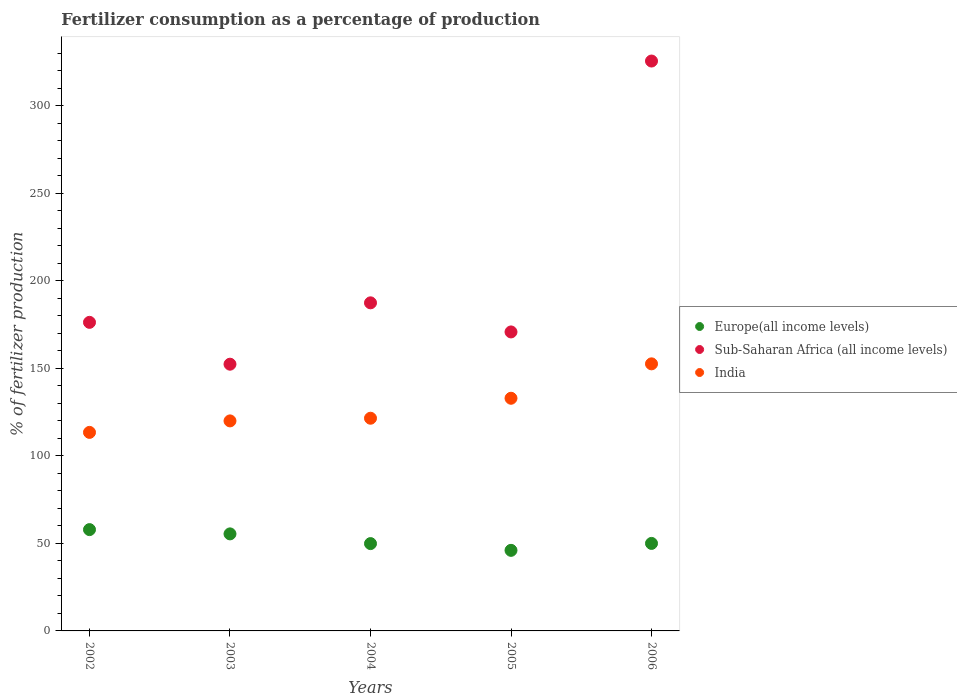Is the number of dotlines equal to the number of legend labels?
Provide a short and direct response. Yes. What is the percentage of fertilizers consumed in Sub-Saharan Africa (all income levels) in 2003?
Make the answer very short. 152.35. Across all years, what is the maximum percentage of fertilizers consumed in Sub-Saharan Africa (all income levels)?
Offer a terse response. 325.51. Across all years, what is the minimum percentage of fertilizers consumed in India?
Provide a short and direct response. 113.4. In which year was the percentage of fertilizers consumed in Europe(all income levels) maximum?
Your response must be concise. 2002. What is the total percentage of fertilizers consumed in India in the graph?
Give a very brief answer. 640.3. What is the difference between the percentage of fertilizers consumed in Europe(all income levels) in 2004 and that in 2005?
Your answer should be very brief. 3.86. What is the difference between the percentage of fertilizers consumed in India in 2002 and the percentage of fertilizers consumed in Sub-Saharan Africa (all income levels) in 2005?
Your answer should be very brief. -57.38. What is the average percentage of fertilizers consumed in Sub-Saharan Africa (all income levels) per year?
Keep it short and to the point. 202.46. In the year 2006, what is the difference between the percentage of fertilizers consumed in Europe(all income levels) and percentage of fertilizers consumed in India?
Give a very brief answer. -102.57. In how many years, is the percentage of fertilizers consumed in Europe(all income levels) greater than 210 %?
Offer a terse response. 0. What is the ratio of the percentage of fertilizers consumed in Sub-Saharan Africa (all income levels) in 2002 to that in 2006?
Offer a terse response. 0.54. Is the difference between the percentage of fertilizers consumed in Europe(all income levels) in 2005 and 2006 greater than the difference between the percentage of fertilizers consumed in India in 2005 and 2006?
Your response must be concise. Yes. What is the difference between the highest and the second highest percentage of fertilizers consumed in India?
Give a very brief answer. 19.66. What is the difference between the highest and the lowest percentage of fertilizers consumed in Europe(all income levels)?
Your answer should be compact. 11.84. Is the sum of the percentage of fertilizers consumed in India in 2002 and 2004 greater than the maximum percentage of fertilizers consumed in Europe(all income levels) across all years?
Provide a short and direct response. Yes. Does the percentage of fertilizers consumed in India monotonically increase over the years?
Your answer should be compact. Yes. Is the percentage of fertilizers consumed in India strictly greater than the percentage of fertilizers consumed in Europe(all income levels) over the years?
Make the answer very short. Yes. How many dotlines are there?
Your response must be concise. 3. Are the values on the major ticks of Y-axis written in scientific E-notation?
Your answer should be compact. No. Does the graph contain any zero values?
Your answer should be compact. No. What is the title of the graph?
Provide a short and direct response. Fertilizer consumption as a percentage of production. Does "Hong Kong" appear as one of the legend labels in the graph?
Ensure brevity in your answer.  No. What is the label or title of the Y-axis?
Ensure brevity in your answer.  % of fertilizer production. What is the % of fertilizer production of Europe(all income levels) in 2002?
Give a very brief answer. 57.87. What is the % of fertilizer production in Sub-Saharan Africa (all income levels) in 2002?
Keep it short and to the point. 176.25. What is the % of fertilizer production in India in 2002?
Your answer should be compact. 113.4. What is the % of fertilizer production in Europe(all income levels) in 2003?
Offer a very short reply. 55.43. What is the % of fertilizer production of Sub-Saharan Africa (all income levels) in 2003?
Offer a very short reply. 152.35. What is the % of fertilizer production in India in 2003?
Give a very brief answer. 119.96. What is the % of fertilizer production in Europe(all income levels) in 2004?
Ensure brevity in your answer.  49.88. What is the % of fertilizer production of Sub-Saharan Africa (all income levels) in 2004?
Provide a succinct answer. 187.4. What is the % of fertilizer production of India in 2004?
Keep it short and to the point. 121.49. What is the % of fertilizer production in Europe(all income levels) in 2005?
Your response must be concise. 46.02. What is the % of fertilizer production in Sub-Saharan Africa (all income levels) in 2005?
Give a very brief answer. 170.78. What is the % of fertilizer production of India in 2005?
Offer a terse response. 132.9. What is the % of fertilizer production in Europe(all income levels) in 2006?
Ensure brevity in your answer.  49.98. What is the % of fertilizer production of Sub-Saharan Africa (all income levels) in 2006?
Provide a short and direct response. 325.51. What is the % of fertilizer production of India in 2006?
Offer a terse response. 152.55. Across all years, what is the maximum % of fertilizer production of Europe(all income levels)?
Keep it short and to the point. 57.87. Across all years, what is the maximum % of fertilizer production of Sub-Saharan Africa (all income levels)?
Provide a short and direct response. 325.51. Across all years, what is the maximum % of fertilizer production of India?
Your response must be concise. 152.55. Across all years, what is the minimum % of fertilizer production of Europe(all income levels)?
Provide a succinct answer. 46.02. Across all years, what is the minimum % of fertilizer production in Sub-Saharan Africa (all income levels)?
Make the answer very short. 152.35. Across all years, what is the minimum % of fertilizer production in India?
Your response must be concise. 113.4. What is the total % of fertilizer production in Europe(all income levels) in the graph?
Your answer should be very brief. 259.18. What is the total % of fertilizer production of Sub-Saharan Africa (all income levels) in the graph?
Provide a short and direct response. 1012.29. What is the total % of fertilizer production in India in the graph?
Your response must be concise. 640.3. What is the difference between the % of fertilizer production of Europe(all income levels) in 2002 and that in 2003?
Provide a short and direct response. 2.44. What is the difference between the % of fertilizer production in Sub-Saharan Africa (all income levels) in 2002 and that in 2003?
Your answer should be compact. 23.9. What is the difference between the % of fertilizer production of India in 2002 and that in 2003?
Your response must be concise. -6.56. What is the difference between the % of fertilizer production of Europe(all income levels) in 2002 and that in 2004?
Your answer should be compact. 7.99. What is the difference between the % of fertilizer production in Sub-Saharan Africa (all income levels) in 2002 and that in 2004?
Your answer should be compact. -11.14. What is the difference between the % of fertilizer production of India in 2002 and that in 2004?
Offer a very short reply. -8.09. What is the difference between the % of fertilizer production in Europe(all income levels) in 2002 and that in 2005?
Provide a succinct answer. 11.84. What is the difference between the % of fertilizer production in Sub-Saharan Africa (all income levels) in 2002 and that in 2005?
Your answer should be compact. 5.48. What is the difference between the % of fertilizer production in India in 2002 and that in 2005?
Give a very brief answer. -19.49. What is the difference between the % of fertilizer production of Europe(all income levels) in 2002 and that in 2006?
Offer a terse response. 7.88. What is the difference between the % of fertilizer production of Sub-Saharan Africa (all income levels) in 2002 and that in 2006?
Your answer should be very brief. -149.25. What is the difference between the % of fertilizer production of India in 2002 and that in 2006?
Give a very brief answer. -39.15. What is the difference between the % of fertilizer production of Europe(all income levels) in 2003 and that in 2004?
Offer a terse response. 5.55. What is the difference between the % of fertilizer production in Sub-Saharan Africa (all income levels) in 2003 and that in 2004?
Give a very brief answer. -35.04. What is the difference between the % of fertilizer production in India in 2003 and that in 2004?
Your answer should be compact. -1.53. What is the difference between the % of fertilizer production in Europe(all income levels) in 2003 and that in 2005?
Provide a short and direct response. 9.4. What is the difference between the % of fertilizer production in Sub-Saharan Africa (all income levels) in 2003 and that in 2005?
Ensure brevity in your answer.  -18.43. What is the difference between the % of fertilizer production of India in 2003 and that in 2005?
Make the answer very short. -12.94. What is the difference between the % of fertilizer production in Europe(all income levels) in 2003 and that in 2006?
Offer a terse response. 5.44. What is the difference between the % of fertilizer production in Sub-Saharan Africa (all income levels) in 2003 and that in 2006?
Your answer should be very brief. -173.16. What is the difference between the % of fertilizer production of India in 2003 and that in 2006?
Offer a terse response. -32.59. What is the difference between the % of fertilizer production in Europe(all income levels) in 2004 and that in 2005?
Provide a short and direct response. 3.86. What is the difference between the % of fertilizer production in Sub-Saharan Africa (all income levels) in 2004 and that in 2005?
Offer a terse response. 16.62. What is the difference between the % of fertilizer production in India in 2004 and that in 2005?
Provide a succinct answer. -11.41. What is the difference between the % of fertilizer production of Europe(all income levels) in 2004 and that in 2006?
Ensure brevity in your answer.  -0.1. What is the difference between the % of fertilizer production in Sub-Saharan Africa (all income levels) in 2004 and that in 2006?
Provide a short and direct response. -138.11. What is the difference between the % of fertilizer production in India in 2004 and that in 2006?
Provide a short and direct response. -31.06. What is the difference between the % of fertilizer production of Europe(all income levels) in 2005 and that in 2006?
Give a very brief answer. -3.96. What is the difference between the % of fertilizer production in Sub-Saharan Africa (all income levels) in 2005 and that in 2006?
Provide a succinct answer. -154.73. What is the difference between the % of fertilizer production in India in 2005 and that in 2006?
Provide a succinct answer. -19.66. What is the difference between the % of fertilizer production in Europe(all income levels) in 2002 and the % of fertilizer production in Sub-Saharan Africa (all income levels) in 2003?
Your response must be concise. -94.49. What is the difference between the % of fertilizer production in Europe(all income levels) in 2002 and the % of fertilizer production in India in 2003?
Make the answer very short. -62.09. What is the difference between the % of fertilizer production of Sub-Saharan Africa (all income levels) in 2002 and the % of fertilizer production of India in 2003?
Provide a succinct answer. 56.29. What is the difference between the % of fertilizer production of Europe(all income levels) in 2002 and the % of fertilizer production of Sub-Saharan Africa (all income levels) in 2004?
Your answer should be compact. -129.53. What is the difference between the % of fertilizer production of Europe(all income levels) in 2002 and the % of fertilizer production of India in 2004?
Keep it short and to the point. -63.62. What is the difference between the % of fertilizer production of Sub-Saharan Africa (all income levels) in 2002 and the % of fertilizer production of India in 2004?
Keep it short and to the point. 54.77. What is the difference between the % of fertilizer production of Europe(all income levels) in 2002 and the % of fertilizer production of Sub-Saharan Africa (all income levels) in 2005?
Offer a very short reply. -112.91. What is the difference between the % of fertilizer production in Europe(all income levels) in 2002 and the % of fertilizer production in India in 2005?
Make the answer very short. -75.03. What is the difference between the % of fertilizer production of Sub-Saharan Africa (all income levels) in 2002 and the % of fertilizer production of India in 2005?
Offer a very short reply. 43.36. What is the difference between the % of fertilizer production of Europe(all income levels) in 2002 and the % of fertilizer production of Sub-Saharan Africa (all income levels) in 2006?
Make the answer very short. -267.64. What is the difference between the % of fertilizer production of Europe(all income levels) in 2002 and the % of fertilizer production of India in 2006?
Your answer should be very brief. -94.68. What is the difference between the % of fertilizer production in Sub-Saharan Africa (all income levels) in 2002 and the % of fertilizer production in India in 2006?
Ensure brevity in your answer.  23.7. What is the difference between the % of fertilizer production in Europe(all income levels) in 2003 and the % of fertilizer production in Sub-Saharan Africa (all income levels) in 2004?
Your answer should be compact. -131.97. What is the difference between the % of fertilizer production of Europe(all income levels) in 2003 and the % of fertilizer production of India in 2004?
Your answer should be very brief. -66.06. What is the difference between the % of fertilizer production in Sub-Saharan Africa (all income levels) in 2003 and the % of fertilizer production in India in 2004?
Offer a terse response. 30.87. What is the difference between the % of fertilizer production of Europe(all income levels) in 2003 and the % of fertilizer production of Sub-Saharan Africa (all income levels) in 2005?
Provide a short and direct response. -115.35. What is the difference between the % of fertilizer production of Europe(all income levels) in 2003 and the % of fertilizer production of India in 2005?
Keep it short and to the point. -77.47. What is the difference between the % of fertilizer production in Sub-Saharan Africa (all income levels) in 2003 and the % of fertilizer production in India in 2005?
Your answer should be compact. 19.46. What is the difference between the % of fertilizer production of Europe(all income levels) in 2003 and the % of fertilizer production of Sub-Saharan Africa (all income levels) in 2006?
Make the answer very short. -270.08. What is the difference between the % of fertilizer production in Europe(all income levels) in 2003 and the % of fertilizer production in India in 2006?
Provide a short and direct response. -97.12. What is the difference between the % of fertilizer production of Sub-Saharan Africa (all income levels) in 2003 and the % of fertilizer production of India in 2006?
Your answer should be very brief. -0.2. What is the difference between the % of fertilizer production of Europe(all income levels) in 2004 and the % of fertilizer production of Sub-Saharan Africa (all income levels) in 2005?
Provide a short and direct response. -120.9. What is the difference between the % of fertilizer production of Europe(all income levels) in 2004 and the % of fertilizer production of India in 2005?
Your response must be concise. -83.02. What is the difference between the % of fertilizer production in Sub-Saharan Africa (all income levels) in 2004 and the % of fertilizer production in India in 2005?
Keep it short and to the point. 54.5. What is the difference between the % of fertilizer production of Europe(all income levels) in 2004 and the % of fertilizer production of Sub-Saharan Africa (all income levels) in 2006?
Provide a short and direct response. -275.63. What is the difference between the % of fertilizer production in Europe(all income levels) in 2004 and the % of fertilizer production in India in 2006?
Keep it short and to the point. -102.67. What is the difference between the % of fertilizer production of Sub-Saharan Africa (all income levels) in 2004 and the % of fertilizer production of India in 2006?
Your answer should be very brief. 34.85. What is the difference between the % of fertilizer production of Europe(all income levels) in 2005 and the % of fertilizer production of Sub-Saharan Africa (all income levels) in 2006?
Offer a very short reply. -279.49. What is the difference between the % of fertilizer production of Europe(all income levels) in 2005 and the % of fertilizer production of India in 2006?
Your answer should be compact. -106.53. What is the difference between the % of fertilizer production of Sub-Saharan Africa (all income levels) in 2005 and the % of fertilizer production of India in 2006?
Your answer should be very brief. 18.23. What is the average % of fertilizer production of Europe(all income levels) per year?
Give a very brief answer. 51.84. What is the average % of fertilizer production in Sub-Saharan Africa (all income levels) per year?
Provide a succinct answer. 202.46. What is the average % of fertilizer production in India per year?
Your answer should be compact. 128.06. In the year 2002, what is the difference between the % of fertilizer production of Europe(all income levels) and % of fertilizer production of Sub-Saharan Africa (all income levels)?
Your answer should be compact. -118.39. In the year 2002, what is the difference between the % of fertilizer production of Europe(all income levels) and % of fertilizer production of India?
Your answer should be very brief. -55.53. In the year 2002, what is the difference between the % of fertilizer production in Sub-Saharan Africa (all income levels) and % of fertilizer production in India?
Your response must be concise. 62.85. In the year 2003, what is the difference between the % of fertilizer production in Europe(all income levels) and % of fertilizer production in Sub-Saharan Africa (all income levels)?
Your answer should be very brief. -96.92. In the year 2003, what is the difference between the % of fertilizer production in Europe(all income levels) and % of fertilizer production in India?
Your response must be concise. -64.53. In the year 2003, what is the difference between the % of fertilizer production in Sub-Saharan Africa (all income levels) and % of fertilizer production in India?
Ensure brevity in your answer.  32.39. In the year 2004, what is the difference between the % of fertilizer production in Europe(all income levels) and % of fertilizer production in Sub-Saharan Africa (all income levels)?
Your answer should be very brief. -137.52. In the year 2004, what is the difference between the % of fertilizer production of Europe(all income levels) and % of fertilizer production of India?
Your response must be concise. -71.61. In the year 2004, what is the difference between the % of fertilizer production in Sub-Saharan Africa (all income levels) and % of fertilizer production in India?
Keep it short and to the point. 65.91. In the year 2005, what is the difference between the % of fertilizer production of Europe(all income levels) and % of fertilizer production of Sub-Saharan Africa (all income levels)?
Give a very brief answer. -124.75. In the year 2005, what is the difference between the % of fertilizer production of Europe(all income levels) and % of fertilizer production of India?
Give a very brief answer. -86.87. In the year 2005, what is the difference between the % of fertilizer production of Sub-Saharan Africa (all income levels) and % of fertilizer production of India?
Your answer should be very brief. 37.88. In the year 2006, what is the difference between the % of fertilizer production in Europe(all income levels) and % of fertilizer production in Sub-Saharan Africa (all income levels)?
Give a very brief answer. -275.53. In the year 2006, what is the difference between the % of fertilizer production of Europe(all income levels) and % of fertilizer production of India?
Make the answer very short. -102.57. In the year 2006, what is the difference between the % of fertilizer production in Sub-Saharan Africa (all income levels) and % of fertilizer production in India?
Your response must be concise. 172.96. What is the ratio of the % of fertilizer production in Europe(all income levels) in 2002 to that in 2003?
Ensure brevity in your answer.  1.04. What is the ratio of the % of fertilizer production in Sub-Saharan Africa (all income levels) in 2002 to that in 2003?
Give a very brief answer. 1.16. What is the ratio of the % of fertilizer production in India in 2002 to that in 2003?
Offer a terse response. 0.95. What is the ratio of the % of fertilizer production in Europe(all income levels) in 2002 to that in 2004?
Provide a short and direct response. 1.16. What is the ratio of the % of fertilizer production in Sub-Saharan Africa (all income levels) in 2002 to that in 2004?
Provide a short and direct response. 0.94. What is the ratio of the % of fertilizer production in India in 2002 to that in 2004?
Keep it short and to the point. 0.93. What is the ratio of the % of fertilizer production of Europe(all income levels) in 2002 to that in 2005?
Offer a terse response. 1.26. What is the ratio of the % of fertilizer production in Sub-Saharan Africa (all income levels) in 2002 to that in 2005?
Keep it short and to the point. 1.03. What is the ratio of the % of fertilizer production in India in 2002 to that in 2005?
Offer a very short reply. 0.85. What is the ratio of the % of fertilizer production in Europe(all income levels) in 2002 to that in 2006?
Give a very brief answer. 1.16. What is the ratio of the % of fertilizer production of Sub-Saharan Africa (all income levels) in 2002 to that in 2006?
Give a very brief answer. 0.54. What is the ratio of the % of fertilizer production of India in 2002 to that in 2006?
Make the answer very short. 0.74. What is the ratio of the % of fertilizer production of Europe(all income levels) in 2003 to that in 2004?
Your answer should be compact. 1.11. What is the ratio of the % of fertilizer production in Sub-Saharan Africa (all income levels) in 2003 to that in 2004?
Offer a terse response. 0.81. What is the ratio of the % of fertilizer production of India in 2003 to that in 2004?
Provide a short and direct response. 0.99. What is the ratio of the % of fertilizer production in Europe(all income levels) in 2003 to that in 2005?
Offer a terse response. 1.2. What is the ratio of the % of fertilizer production in Sub-Saharan Africa (all income levels) in 2003 to that in 2005?
Keep it short and to the point. 0.89. What is the ratio of the % of fertilizer production of India in 2003 to that in 2005?
Provide a short and direct response. 0.9. What is the ratio of the % of fertilizer production of Europe(all income levels) in 2003 to that in 2006?
Keep it short and to the point. 1.11. What is the ratio of the % of fertilizer production in Sub-Saharan Africa (all income levels) in 2003 to that in 2006?
Your response must be concise. 0.47. What is the ratio of the % of fertilizer production of India in 2003 to that in 2006?
Make the answer very short. 0.79. What is the ratio of the % of fertilizer production in Europe(all income levels) in 2004 to that in 2005?
Offer a terse response. 1.08. What is the ratio of the % of fertilizer production of Sub-Saharan Africa (all income levels) in 2004 to that in 2005?
Your answer should be compact. 1.1. What is the ratio of the % of fertilizer production of India in 2004 to that in 2005?
Provide a short and direct response. 0.91. What is the ratio of the % of fertilizer production in Europe(all income levels) in 2004 to that in 2006?
Make the answer very short. 1. What is the ratio of the % of fertilizer production of Sub-Saharan Africa (all income levels) in 2004 to that in 2006?
Your answer should be compact. 0.58. What is the ratio of the % of fertilizer production in India in 2004 to that in 2006?
Offer a very short reply. 0.8. What is the ratio of the % of fertilizer production in Europe(all income levels) in 2005 to that in 2006?
Make the answer very short. 0.92. What is the ratio of the % of fertilizer production in Sub-Saharan Africa (all income levels) in 2005 to that in 2006?
Provide a short and direct response. 0.52. What is the ratio of the % of fertilizer production in India in 2005 to that in 2006?
Give a very brief answer. 0.87. What is the difference between the highest and the second highest % of fertilizer production of Europe(all income levels)?
Make the answer very short. 2.44. What is the difference between the highest and the second highest % of fertilizer production of Sub-Saharan Africa (all income levels)?
Provide a succinct answer. 138.11. What is the difference between the highest and the second highest % of fertilizer production in India?
Your answer should be compact. 19.66. What is the difference between the highest and the lowest % of fertilizer production in Europe(all income levels)?
Keep it short and to the point. 11.84. What is the difference between the highest and the lowest % of fertilizer production in Sub-Saharan Africa (all income levels)?
Keep it short and to the point. 173.16. What is the difference between the highest and the lowest % of fertilizer production in India?
Your answer should be very brief. 39.15. 